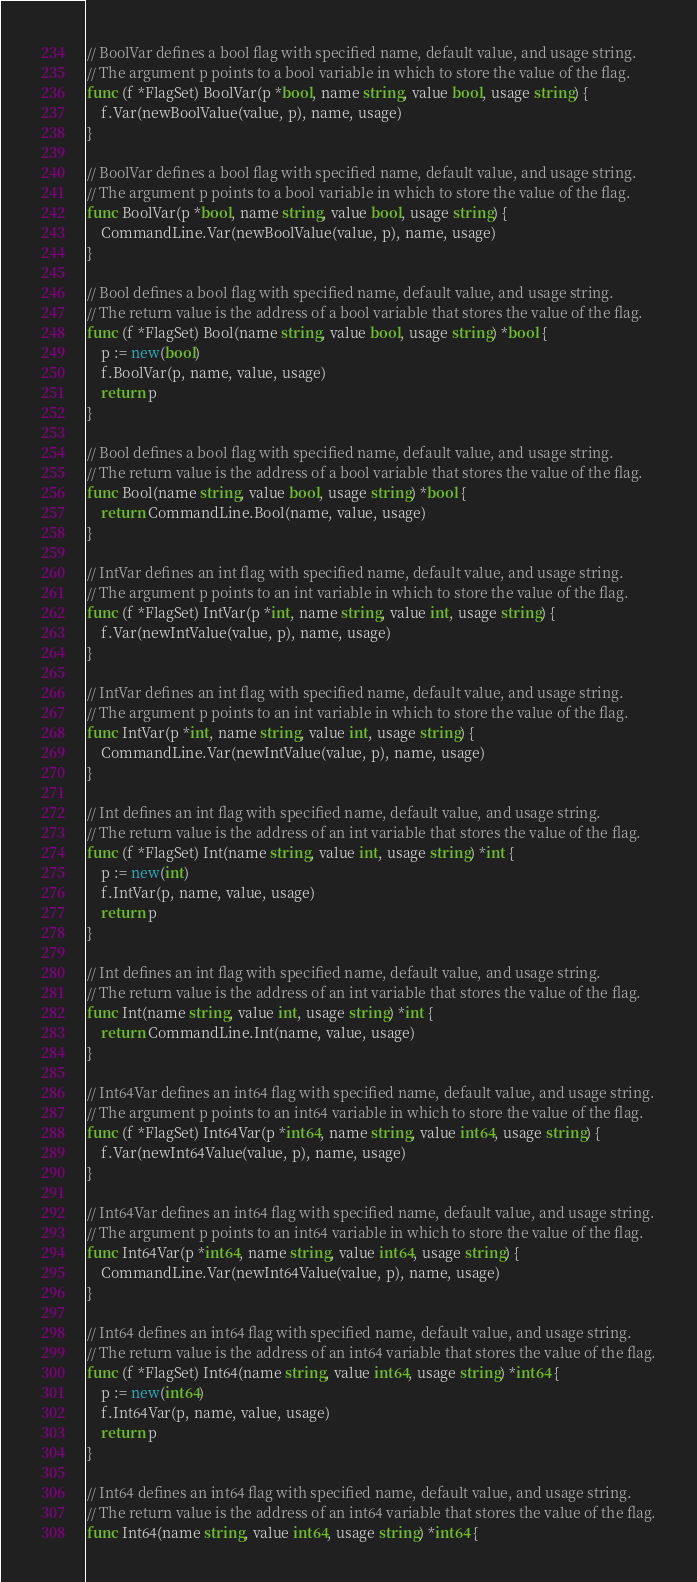<code> <loc_0><loc_0><loc_500><loc_500><_Go_>// BoolVar defines a bool flag with specified name, default value, and usage string.
// The argument p points to a bool variable in which to store the value of the flag.
func (f *FlagSet) BoolVar(p *bool, name string, value bool, usage string) {
	f.Var(newBoolValue(value, p), name, usage)
}

// BoolVar defines a bool flag with specified name, default value, and usage string.
// The argument p points to a bool variable in which to store the value of the flag.
func BoolVar(p *bool, name string, value bool, usage string) {
	CommandLine.Var(newBoolValue(value, p), name, usage)
}

// Bool defines a bool flag with specified name, default value, and usage string.
// The return value is the address of a bool variable that stores the value of the flag.
func (f *FlagSet) Bool(name string, value bool, usage string) *bool {
	p := new(bool)
	f.BoolVar(p, name, value, usage)
	return p
}

// Bool defines a bool flag with specified name, default value, and usage string.
// The return value is the address of a bool variable that stores the value of the flag.
func Bool(name string, value bool, usage string) *bool {
	return CommandLine.Bool(name, value, usage)
}

// IntVar defines an int flag with specified name, default value, and usage string.
// The argument p points to an int variable in which to store the value of the flag.
func (f *FlagSet) IntVar(p *int, name string, value int, usage string) {
	f.Var(newIntValue(value, p), name, usage)
}

// IntVar defines an int flag with specified name, default value, and usage string.
// The argument p points to an int variable in which to store the value of the flag.
func IntVar(p *int, name string, value int, usage string) {
	CommandLine.Var(newIntValue(value, p), name, usage)
}

// Int defines an int flag with specified name, default value, and usage string.
// The return value is the address of an int variable that stores the value of the flag.
func (f *FlagSet) Int(name string, value int, usage string) *int {
	p := new(int)
	f.IntVar(p, name, value, usage)
	return p
}

// Int defines an int flag with specified name, default value, and usage string.
// The return value is the address of an int variable that stores the value of the flag.
func Int(name string, value int, usage string) *int {
	return CommandLine.Int(name, value, usage)
}

// Int64Var defines an int64 flag with specified name, default value, and usage string.
// The argument p points to an int64 variable in which to store the value of the flag.
func (f *FlagSet) Int64Var(p *int64, name string, value int64, usage string) {
	f.Var(newInt64Value(value, p), name, usage)
}

// Int64Var defines an int64 flag with specified name, default value, and usage string.
// The argument p points to an int64 variable in which to store the value of the flag.
func Int64Var(p *int64, name string, value int64, usage string) {
	CommandLine.Var(newInt64Value(value, p), name, usage)
}

// Int64 defines an int64 flag with specified name, default value, and usage string.
// The return value is the address of an int64 variable that stores the value of the flag.
func (f *FlagSet) Int64(name string, value int64, usage string) *int64 {
	p := new(int64)
	f.Int64Var(p, name, value, usage)
	return p
}

// Int64 defines an int64 flag with specified name, default value, and usage string.
// The return value is the address of an int64 variable that stores the value of the flag.
func Int64(name string, value int64, usage string) *int64 {</code> 